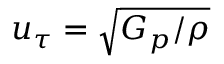<formula> <loc_0><loc_0><loc_500><loc_500>u _ { \tau } = \sqrt { G _ { p } / \rho }</formula> 